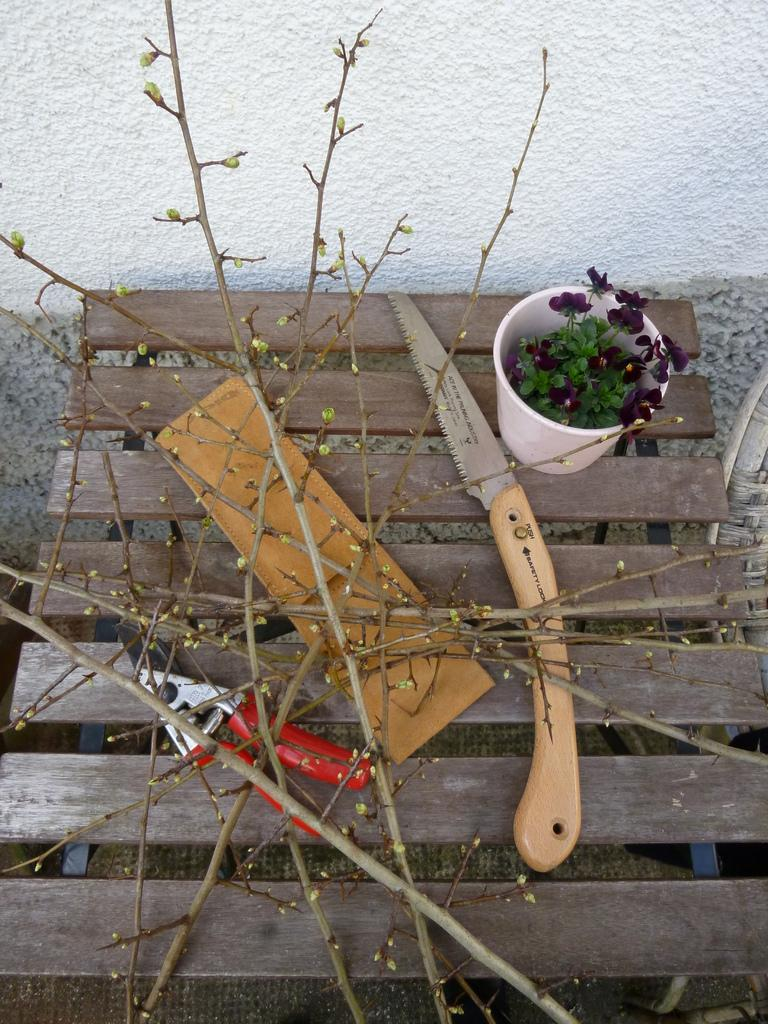What objects can be seen on the table in the foreground of the image? There is a knife, a flower pot, a leather object, and branches of plants on the table in the foreground of the image. What other tool is present on the table in the foreground of the image? There is a cutter on the table in the foreground of the image. What can be seen in the background of the image? There is a wall in the background of the image. How many leaves are on the twig in the image? There is no twig or leaf present in the image. What sense is being stimulated by the objects on the table in the image? The provided facts do not mention any sensory stimulation; the conversation focuses on the visual aspects of the image. 